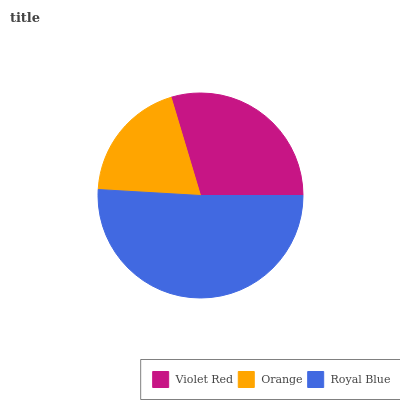Is Orange the minimum?
Answer yes or no. Yes. Is Royal Blue the maximum?
Answer yes or no. Yes. Is Royal Blue the minimum?
Answer yes or no. No. Is Orange the maximum?
Answer yes or no. No. Is Royal Blue greater than Orange?
Answer yes or no. Yes. Is Orange less than Royal Blue?
Answer yes or no. Yes. Is Orange greater than Royal Blue?
Answer yes or no. No. Is Royal Blue less than Orange?
Answer yes or no. No. Is Violet Red the high median?
Answer yes or no. Yes. Is Violet Red the low median?
Answer yes or no. Yes. Is Royal Blue the high median?
Answer yes or no. No. Is Royal Blue the low median?
Answer yes or no. No. 